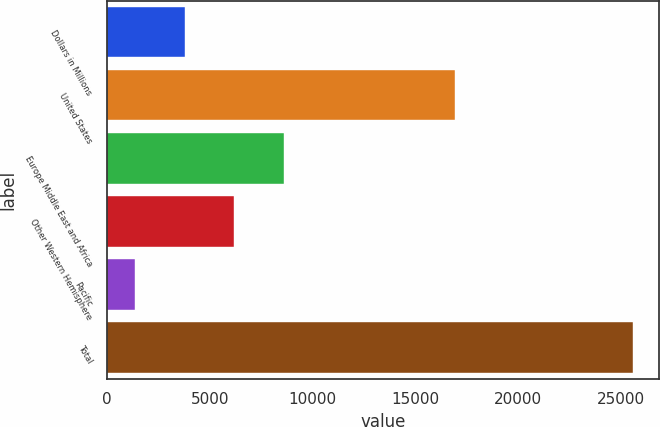Convert chart. <chart><loc_0><loc_0><loc_500><loc_500><bar_chart><fcel>Dollars in Millions<fcel>United States<fcel>Europe Middle East and Africa<fcel>Other Western Hemisphere<fcel>Pacific<fcel>Total<nl><fcel>3785.1<fcel>16942<fcel>8627.3<fcel>6206.2<fcel>1364<fcel>25575<nl></chart> 